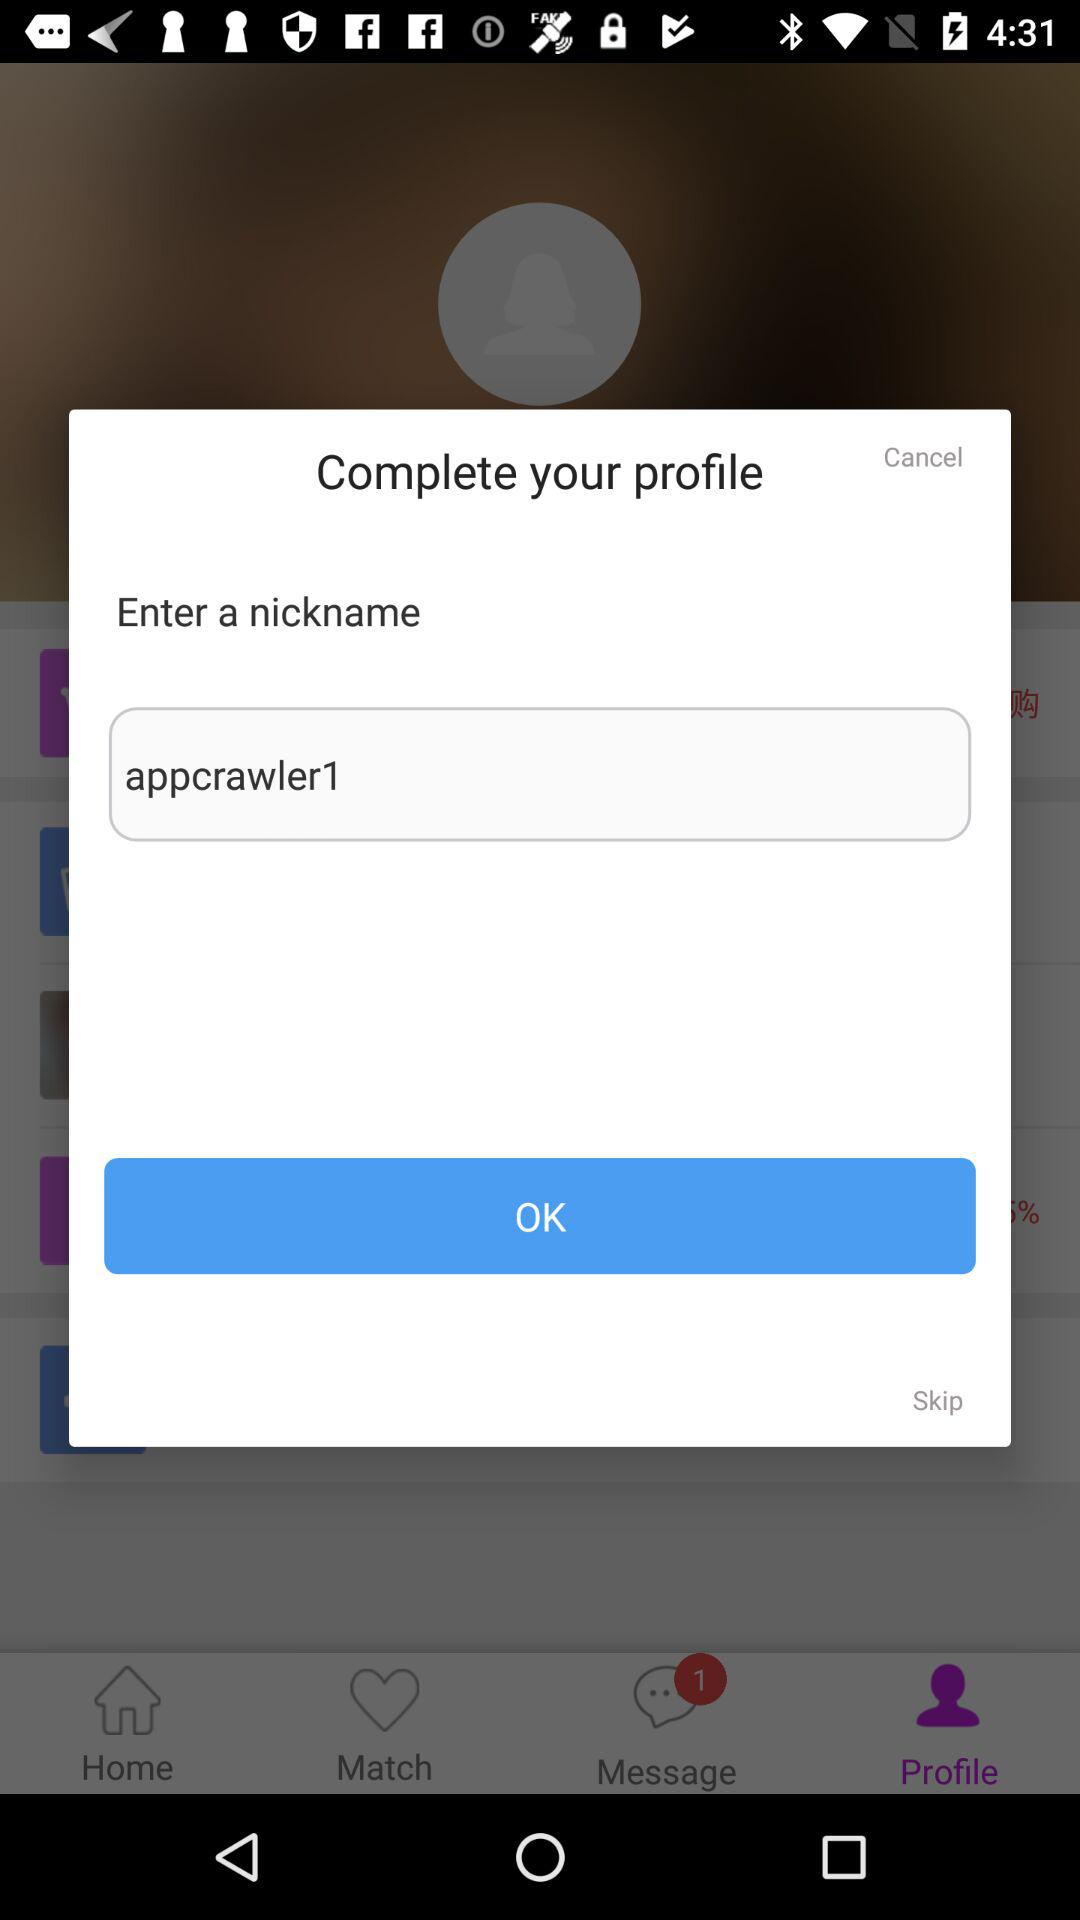How many matches are there?
When the provided information is insufficient, respond with <no answer>. <no answer> 